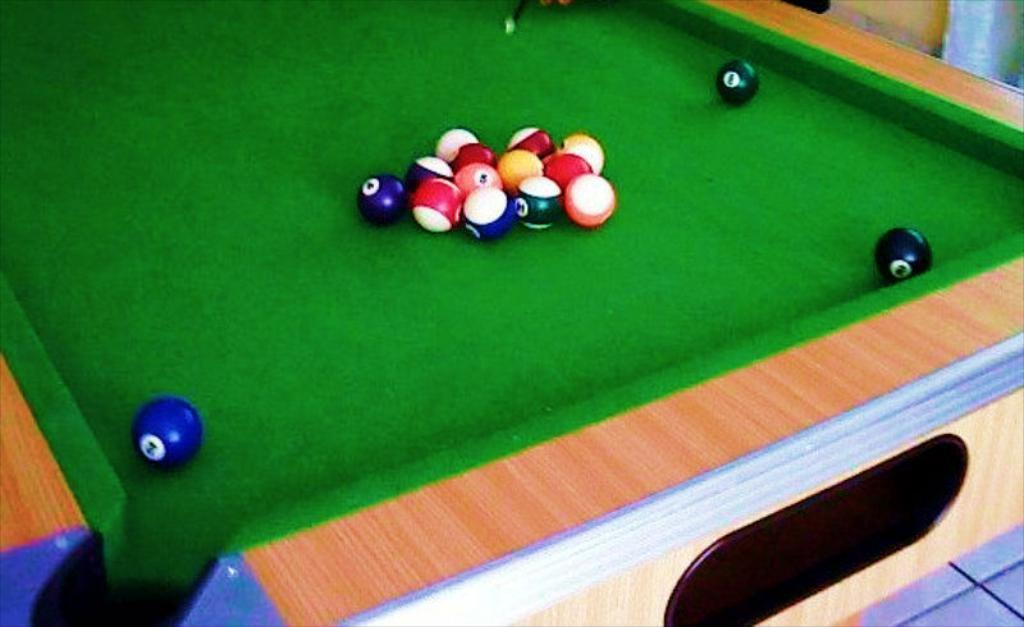What game is being played in the image? The image features a snooker board, which is used for playing snooker. What objects are present on the snooker board? There are balls on the snooker board. Can you describe the appearance of the balls on the snooker board? The balls on the snooker board are of different colors. What type of rod is the queen holding in the image? There is no queen or rod present in the image; it features a snooker board with balls of different colors. 